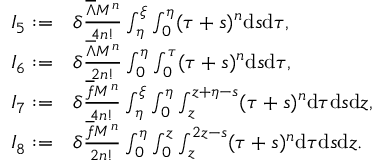Convert formula to latex. <formula><loc_0><loc_0><loc_500><loc_500>\begin{array} { r l } { I _ { 5 } \colon = } & { \delta \frac { { { \overline { \Lambda } } } M ^ { n } } { 4 n ! } \int _ { \eta } ^ { \xi } \int _ { 0 } ^ { \eta } ( \tau + s ) ^ { n } d s d \tau , } \\ { I _ { 6 } \colon = } & { \delta \frac { { { \overline { \Lambda } } } M ^ { n } } { 2 n ! } \int _ { 0 } ^ { \eta } \int _ { 0 } ^ { \tau } ( \tau + s ) ^ { n } d s d \tau , } \\ { I _ { 7 } \colon = } & { \delta \frac { \overline { f } M ^ { n } } { 4 n ! } \int _ { \eta } ^ { \xi } \int _ { 0 } ^ { \eta } \int _ { z } ^ { z + \eta - s } ( \tau + s ) ^ { n } d \tau d s d z , } \\ { I _ { 8 } \colon = } & { \delta \frac { \overline { f } M ^ { n } } { 2 n ! } \int _ { 0 } ^ { \eta } \int _ { 0 } ^ { z } \int _ { z } ^ { 2 z - s } ( \tau + s ) ^ { n } d \tau d s d z . } \end{array}</formula> 